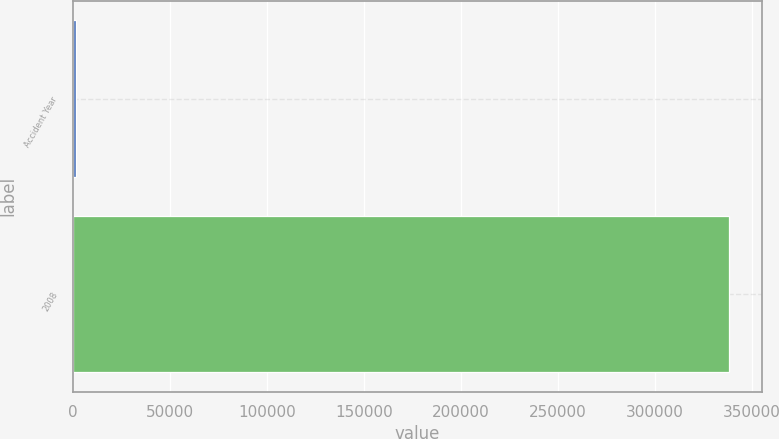<chart> <loc_0><loc_0><loc_500><loc_500><bar_chart><fcel>Accident Year<fcel>2008<nl><fcel>2009<fcel>338299<nl></chart> 